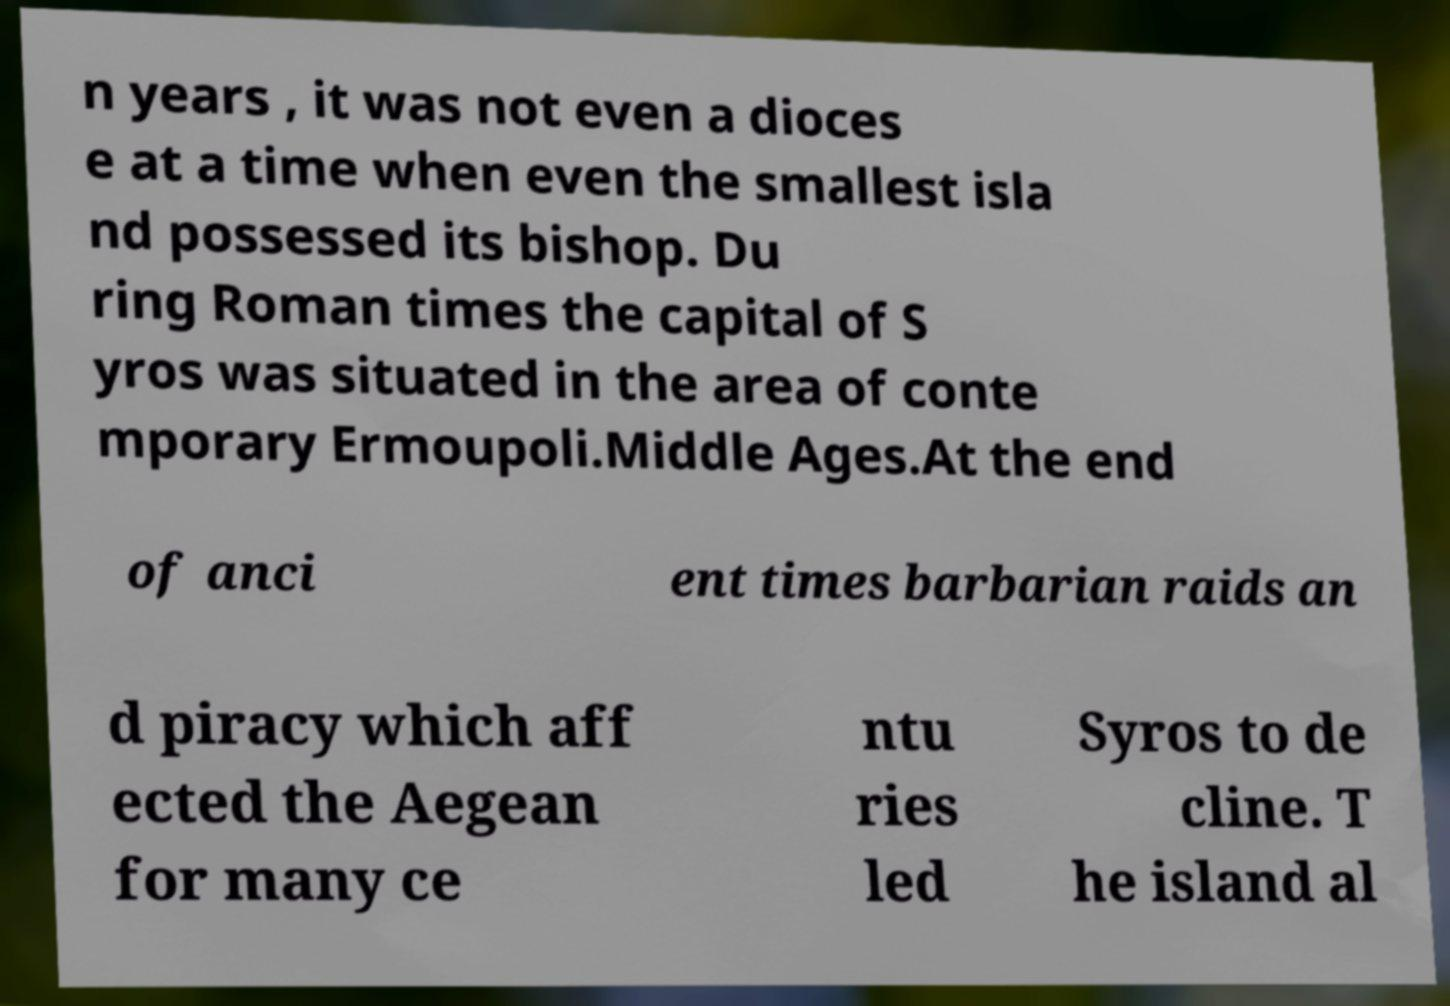What messages or text are displayed in this image? I need them in a readable, typed format. n years , it was not even a dioces e at a time when even the smallest isla nd possessed its bishop. Du ring Roman times the capital of S yros was situated in the area of conte mporary Ermoupoli.Middle Ages.At the end of anci ent times barbarian raids an d piracy which aff ected the Aegean for many ce ntu ries led Syros to de cline. T he island al 